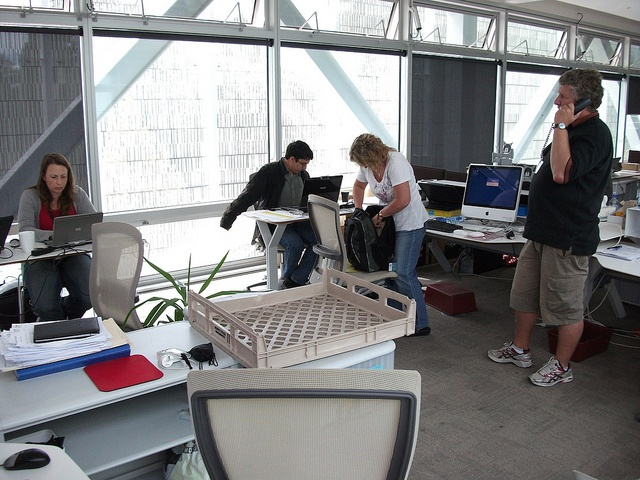Describe the objects in this image and their specific colors. I can see chair in white, darkgray, black, and gray tones, people in white, black, gray, and maroon tones, people in white, black, gray, and maroon tones, people in white, darkgray, gray, navy, and black tones, and people in white, black, gray, lightgray, and darkgray tones in this image. 